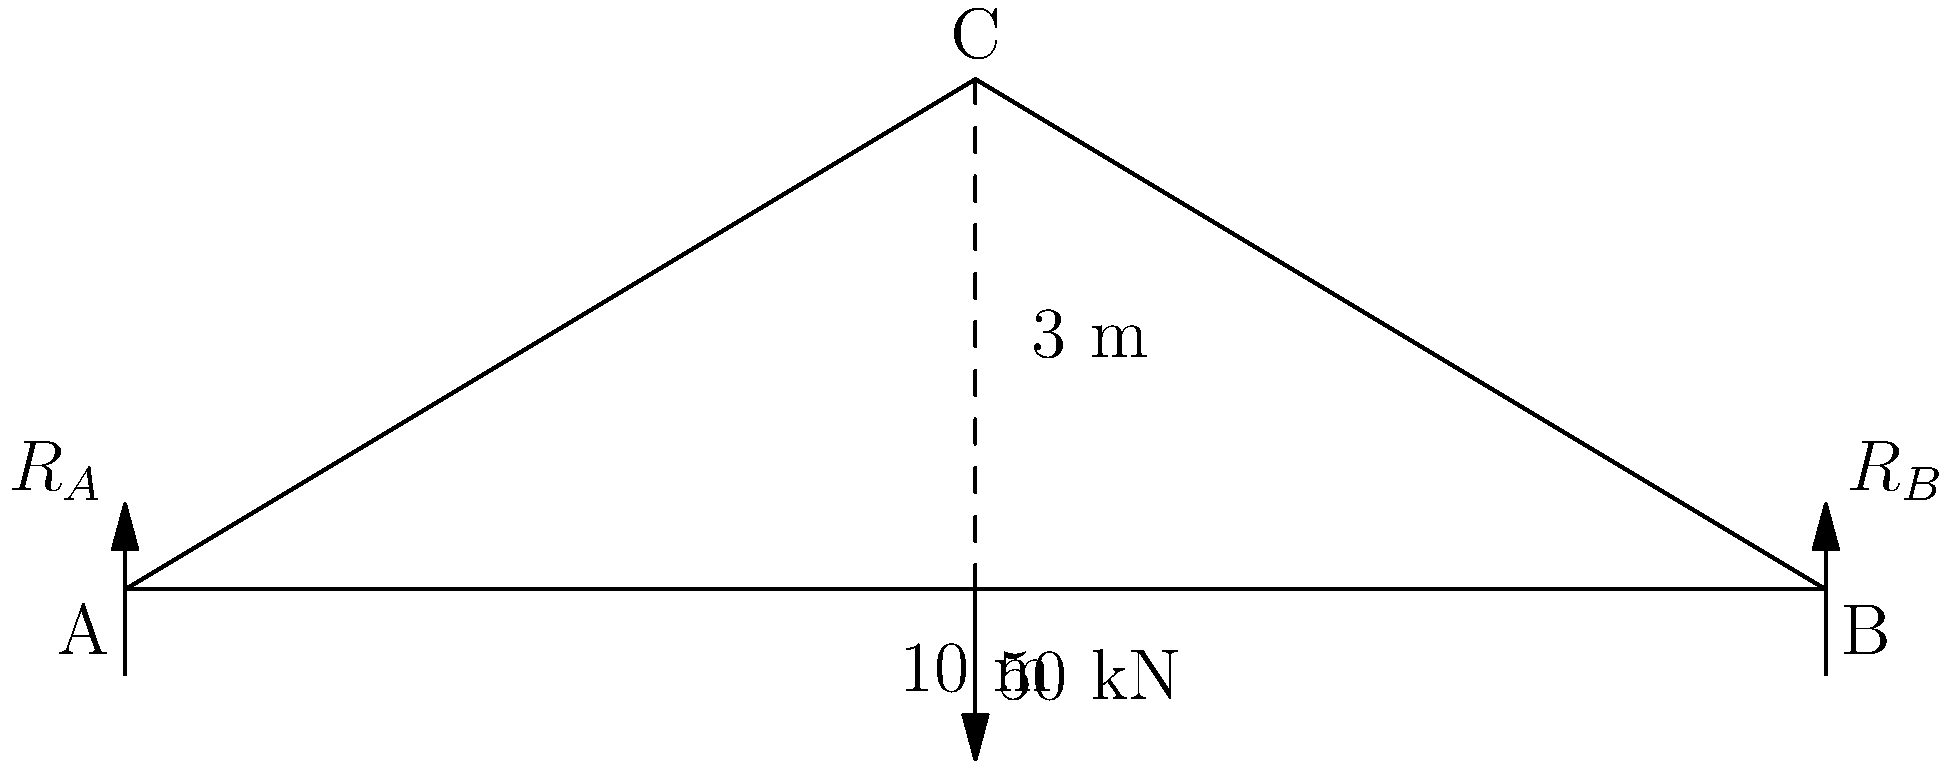In a postmodern deconstruction of structural forces, consider a simple truss bridge with a central load. The bridge span is 10 meters, and the apex is 3 meters above the supports. A vertical load of 50 kN is applied at the apex. Determine the magnitude of the reaction forces at the supports, $R_A$ and $R_B$, assuming they are equal. How might this symmetry of forces reflect the balance of narrative elements in postmodern literature? Let's approach this problem with a postmodern lens, deconstructing the forces at play:

1) First, we recognize the symmetry of the structure, much like the symmetry often subverted in postmodern narratives. The load is applied at the center, suggesting equal reaction forces at both supports.

2) We can use the principle of equilibrium, a foundational "grand narrative" in structural engineering:
   $$\sum F_y = 0$$
   $$R_A + R_B - 50 \text{ kN} = 0$$

3) Given the symmetry, we can assert:
   $$R_A = R_B = R$$

4) Substituting into our equilibrium equation:
   $$R + R - 50 \text{ kN} = 0$$
   $$2R = 50 \text{ kN}$$

5) Solving for R:
   $$R = 25 \text{ kN}$$

6) Therefore, both $R_A$ and $R_B$ are 25 kN.

This equal distribution of forces mirrors the postmodern tendency to decentralize narrative authority, distributing it equally among multiple perspectives or interpretations.
Answer: $R_A = R_B = 25 \text{ kN}$ 